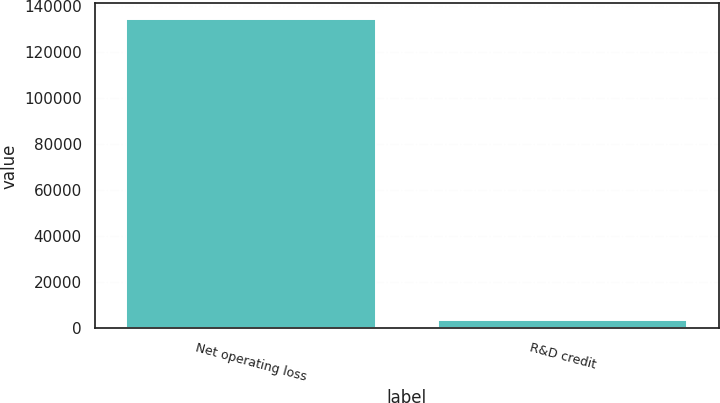Convert chart to OTSL. <chart><loc_0><loc_0><loc_500><loc_500><bar_chart><fcel>Net operating loss<fcel>R&D credit<nl><fcel>134196<fcel>3502<nl></chart> 